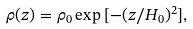Convert formula to latex. <formula><loc_0><loc_0><loc_500><loc_500>\rho ( z ) = \rho _ { 0 } \exp { [ - ( z / H _ { 0 } ) ^ { 2 } ] } ,</formula> 